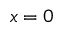Convert formula to latex. <formula><loc_0><loc_0><loc_500><loc_500>x = 0</formula> 